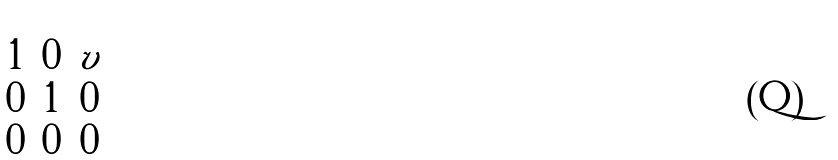<formula> <loc_0><loc_0><loc_500><loc_500>\begin{pmatrix} 1 & 0 & v \\ 0 & 1 & 0 \\ 0 & 0 & 0 \\ \end{pmatrix}</formula> 